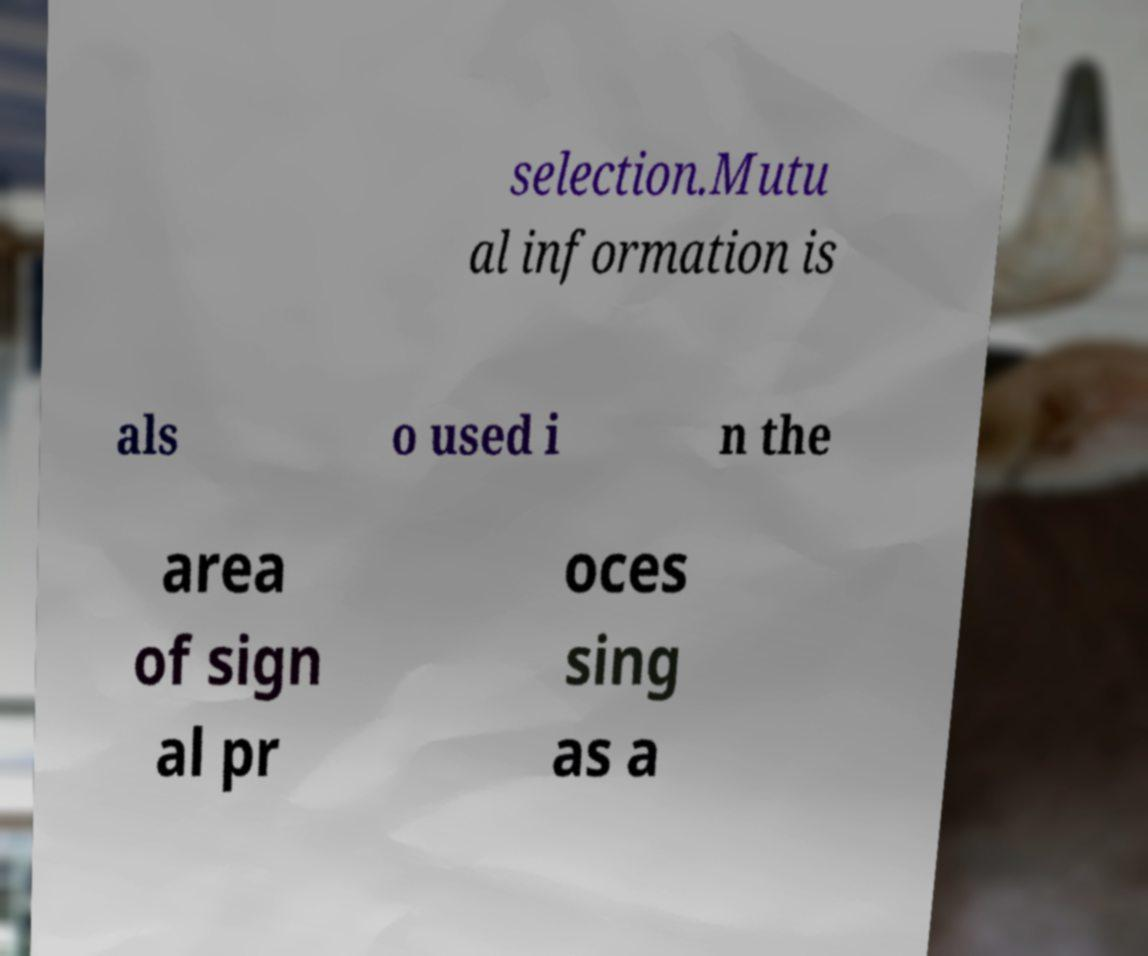Can you accurately transcribe the text from the provided image for me? selection.Mutu al information is als o used i n the area of sign al pr oces sing as a 